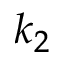<formula> <loc_0><loc_0><loc_500><loc_500>k _ { 2 }</formula> 